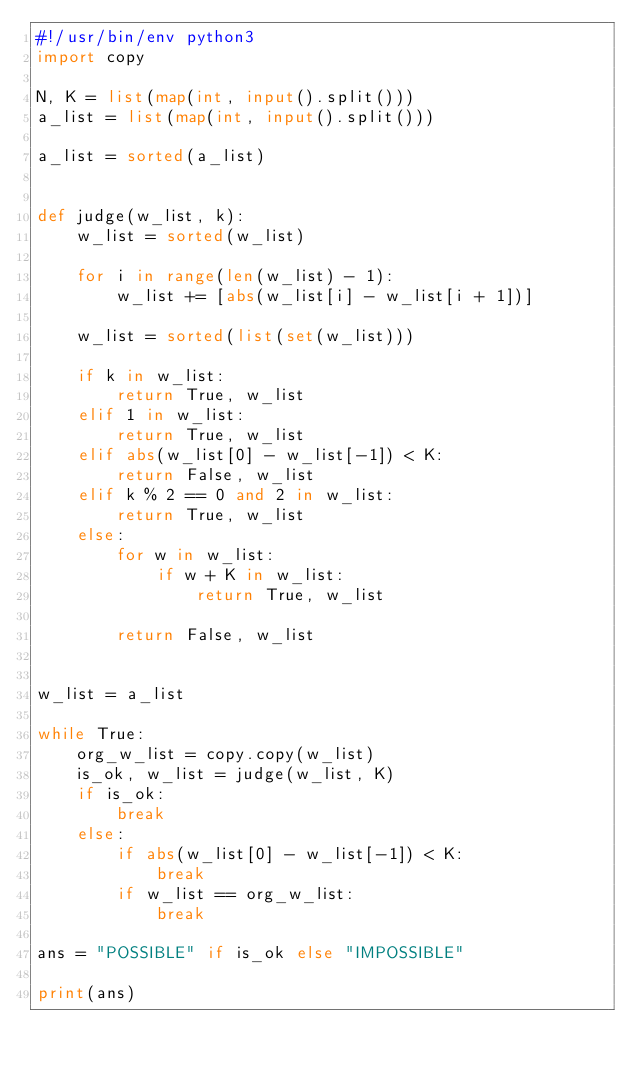<code> <loc_0><loc_0><loc_500><loc_500><_Python_>#!/usr/bin/env python3
import copy

N, K = list(map(int, input().split()))
a_list = list(map(int, input().split()))

a_list = sorted(a_list)


def judge(w_list, k):
    w_list = sorted(w_list)

    for i in range(len(w_list) - 1):
        w_list += [abs(w_list[i] - w_list[i + 1])]

    w_list = sorted(list(set(w_list)))

    if k in w_list:
        return True, w_list
    elif 1 in w_list:
        return True, w_list
    elif abs(w_list[0] - w_list[-1]) < K:
        return False, w_list
    elif k % 2 == 0 and 2 in w_list:
        return True, w_list
    else:
        for w in w_list:
            if w + K in w_list:
                return True, w_list

        return False, w_list


w_list = a_list

while True:
    org_w_list = copy.copy(w_list)
    is_ok, w_list = judge(w_list, K)
    if is_ok:
        break
    else:
        if abs(w_list[0] - w_list[-1]) < K:
            break
        if w_list == org_w_list:
            break

ans = "POSSIBLE" if is_ok else "IMPOSSIBLE"

print(ans)
</code> 